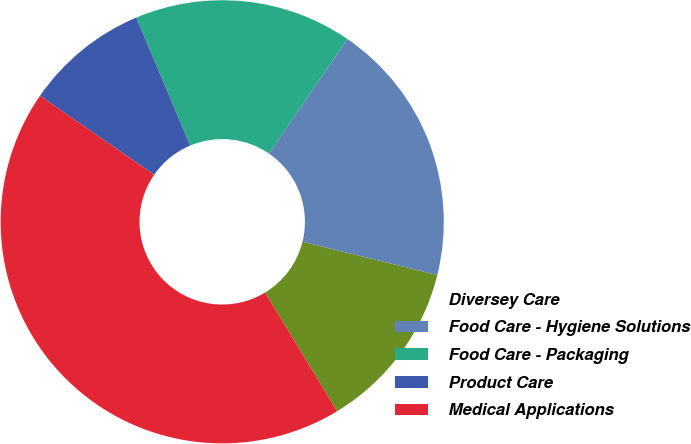<chart> <loc_0><loc_0><loc_500><loc_500><pie_chart><fcel>Diversey Care<fcel>Food Care - Hygiene Solutions<fcel>Food Care - Packaging<fcel>Product Care<fcel>Medical Applications<nl><fcel>12.46%<fcel>19.31%<fcel>15.89%<fcel>9.03%<fcel>43.3%<nl></chart> 